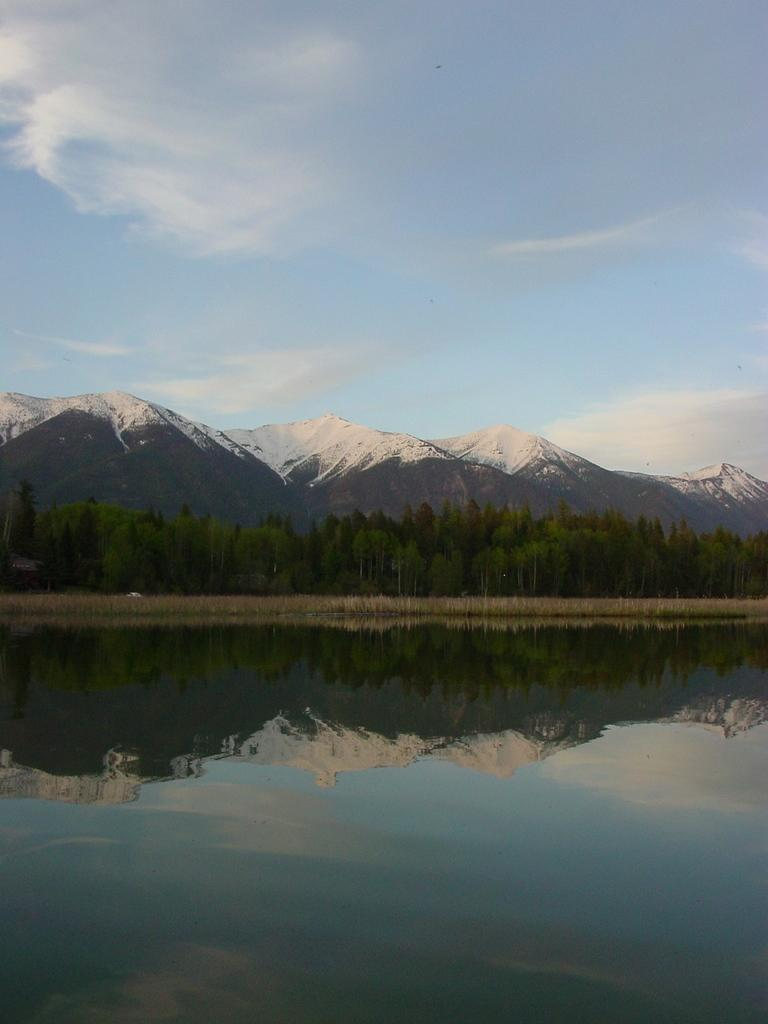What is in the foreground of the image? There is water in the foreground of the image. What can be seen in the background of the image? There are mountains and trees in the background of the image. What is visible in the sky in the image? The sky is visible in the image, and clouds are present. What type of health event is taking place in the image? A: There is no health event present in the image; it features water, mountains, trees, and clouds. Can you describe the argument between the mountains and the trees in the image? There is no argument between the mountains and the trees in the image; they are simply depicted in the background. 